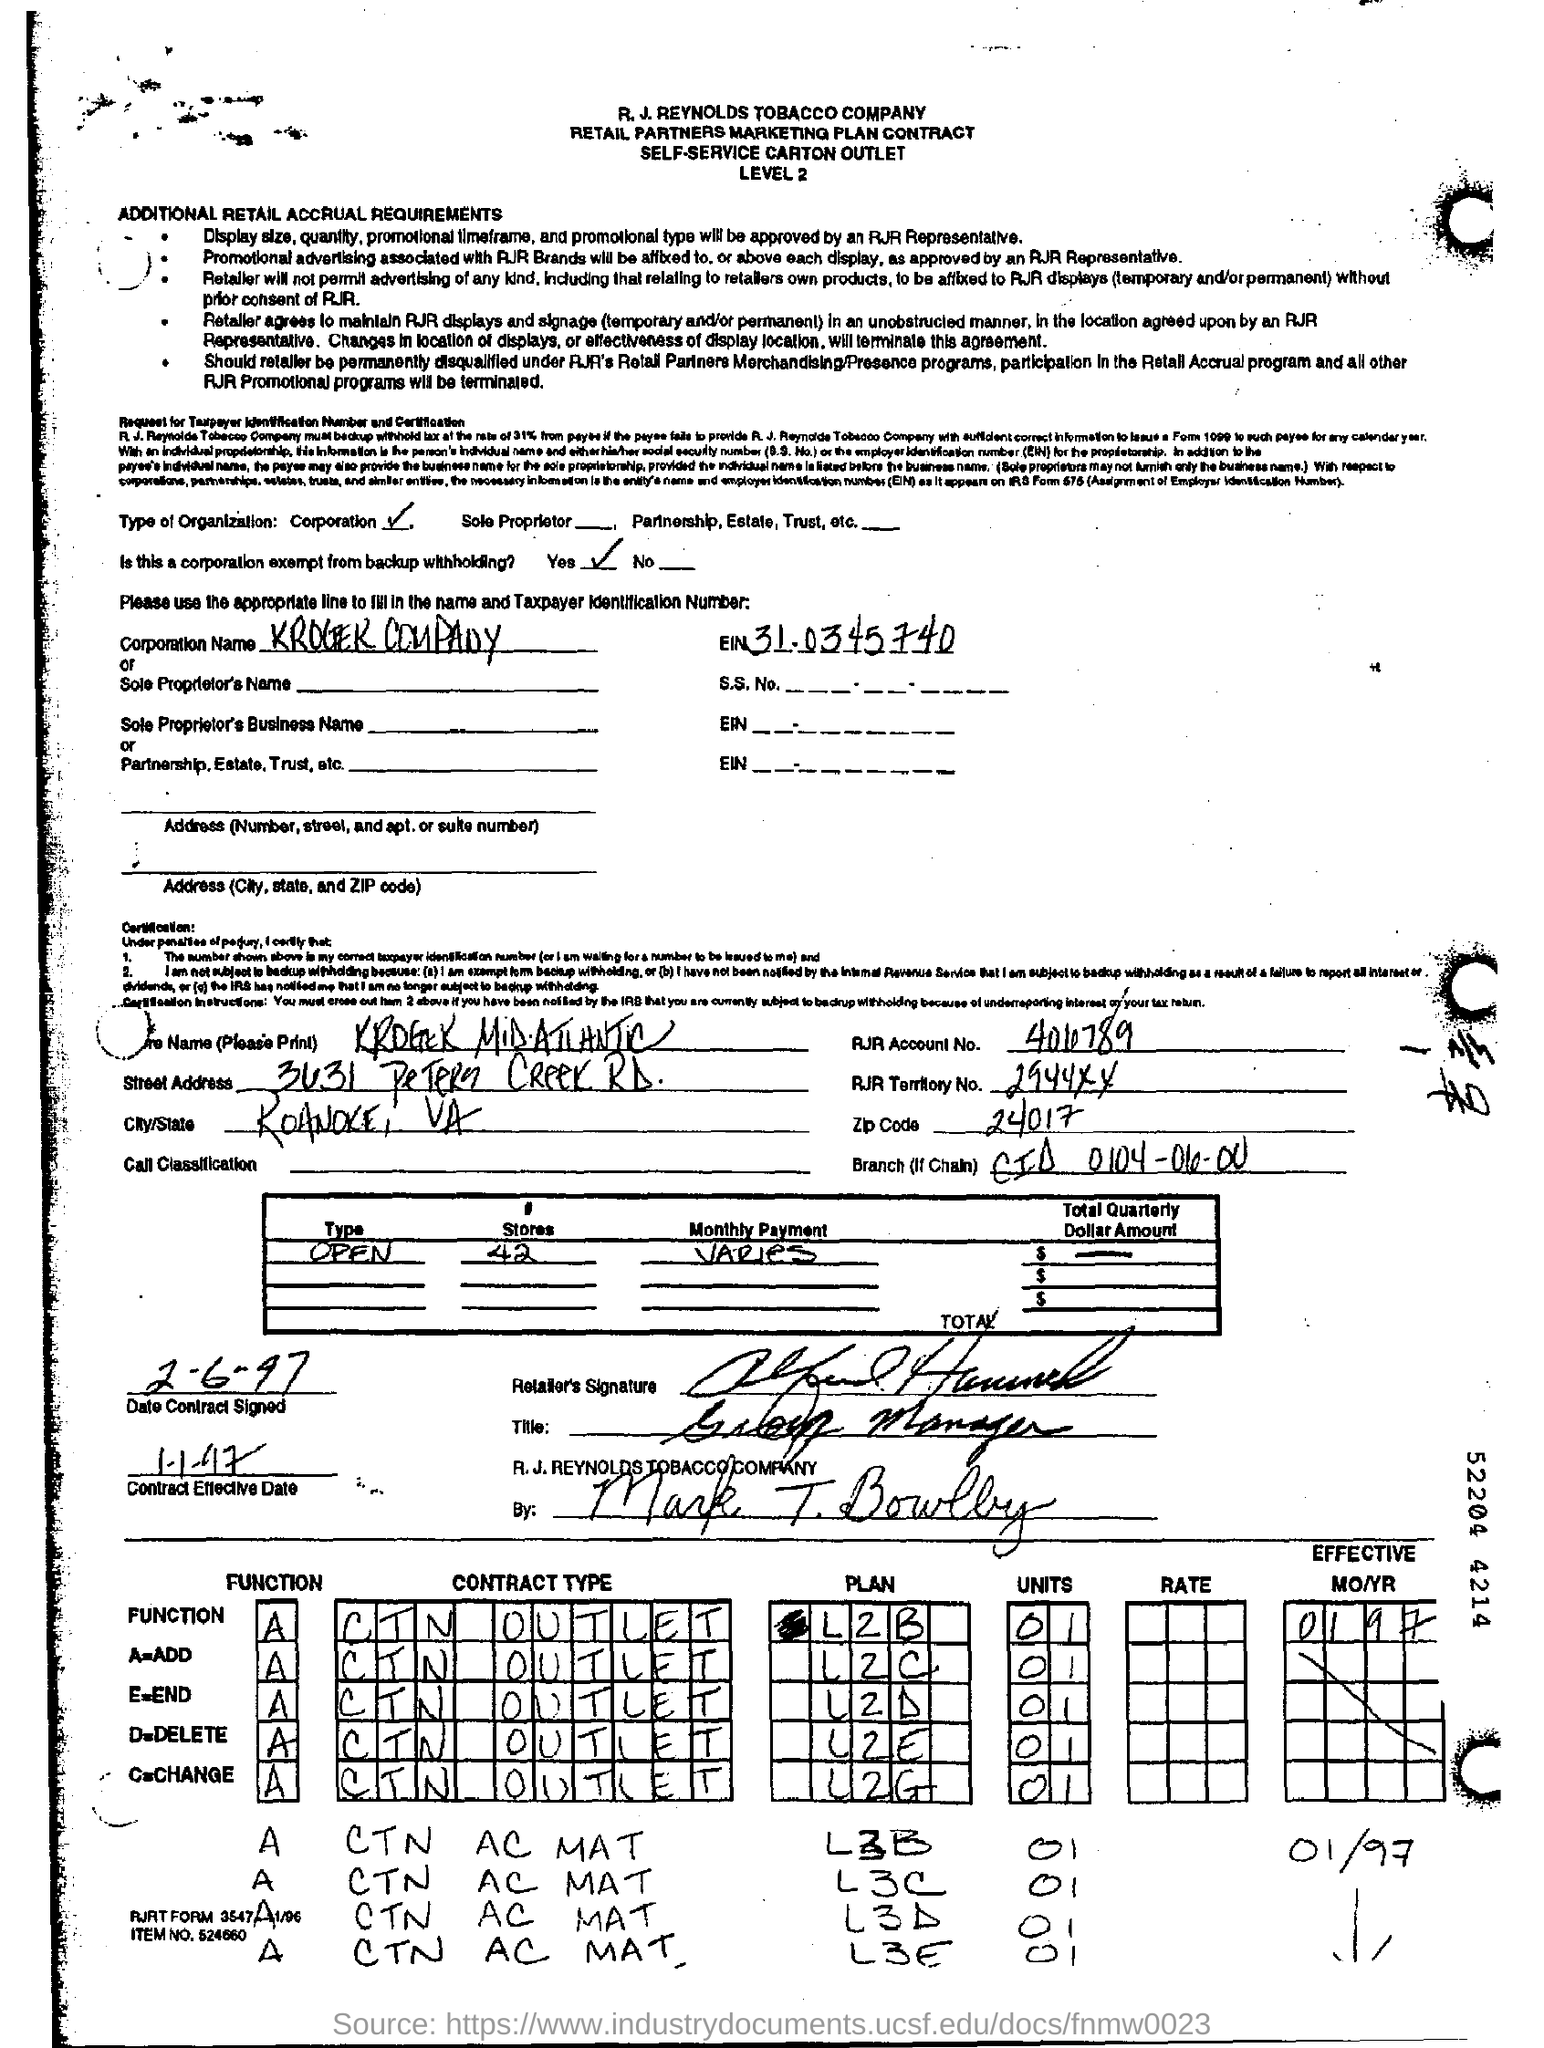Indicate a few pertinent items in this graphic. There are 42 stores. The function A is unknown. The zipcode is 24017. The item number is 524660... The type of organization being referred to is a corporation. 